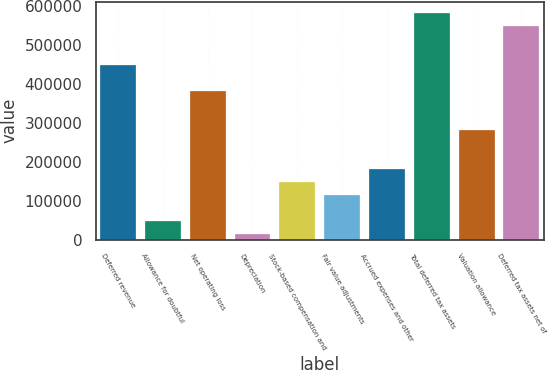Convert chart to OTSL. <chart><loc_0><loc_0><loc_500><loc_500><bar_chart><fcel>Deferred revenue<fcel>Allowance for doubtful<fcel>Net operating loss<fcel>Depreciation<fcel>Stock-based compensation and<fcel>Fair value adjustments<fcel>Accrued expenses and other<fcel>Total deferred tax assets<fcel>Valuation allowance<fcel>Deferred tax assets net of<nl><fcel>449211<fcel>48795.9<fcel>382475<fcel>15428<fcel>148900<fcel>115532<fcel>182268<fcel>582682<fcel>282371<fcel>549314<nl></chart> 